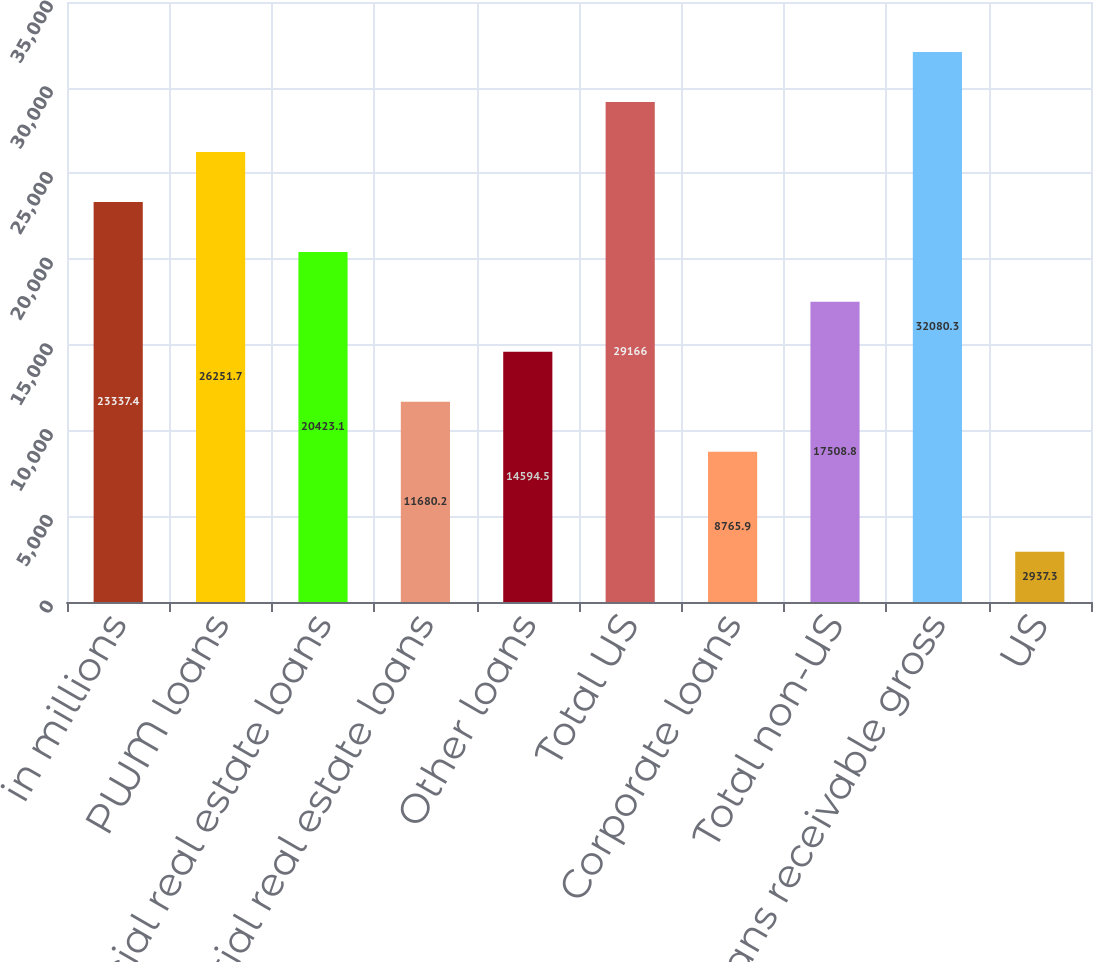Convert chart to OTSL. <chart><loc_0><loc_0><loc_500><loc_500><bar_chart><fcel>in millions<fcel>PWM loans<fcel>Commercial real estate loans<fcel>Residential real estate loans<fcel>Other loans<fcel>Total US<fcel>Corporate loans<fcel>Total non-US<fcel>Total loans receivable gross<fcel>US<nl><fcel>23337.4<fcel>26251.7<fcel>20423.1<fcel>11680.2<fcel>14594.5<fcel>29166<fcel>8765.9<fcel>17508.8<fcel>32080.3<fcel>2937.3<nl></chart> 